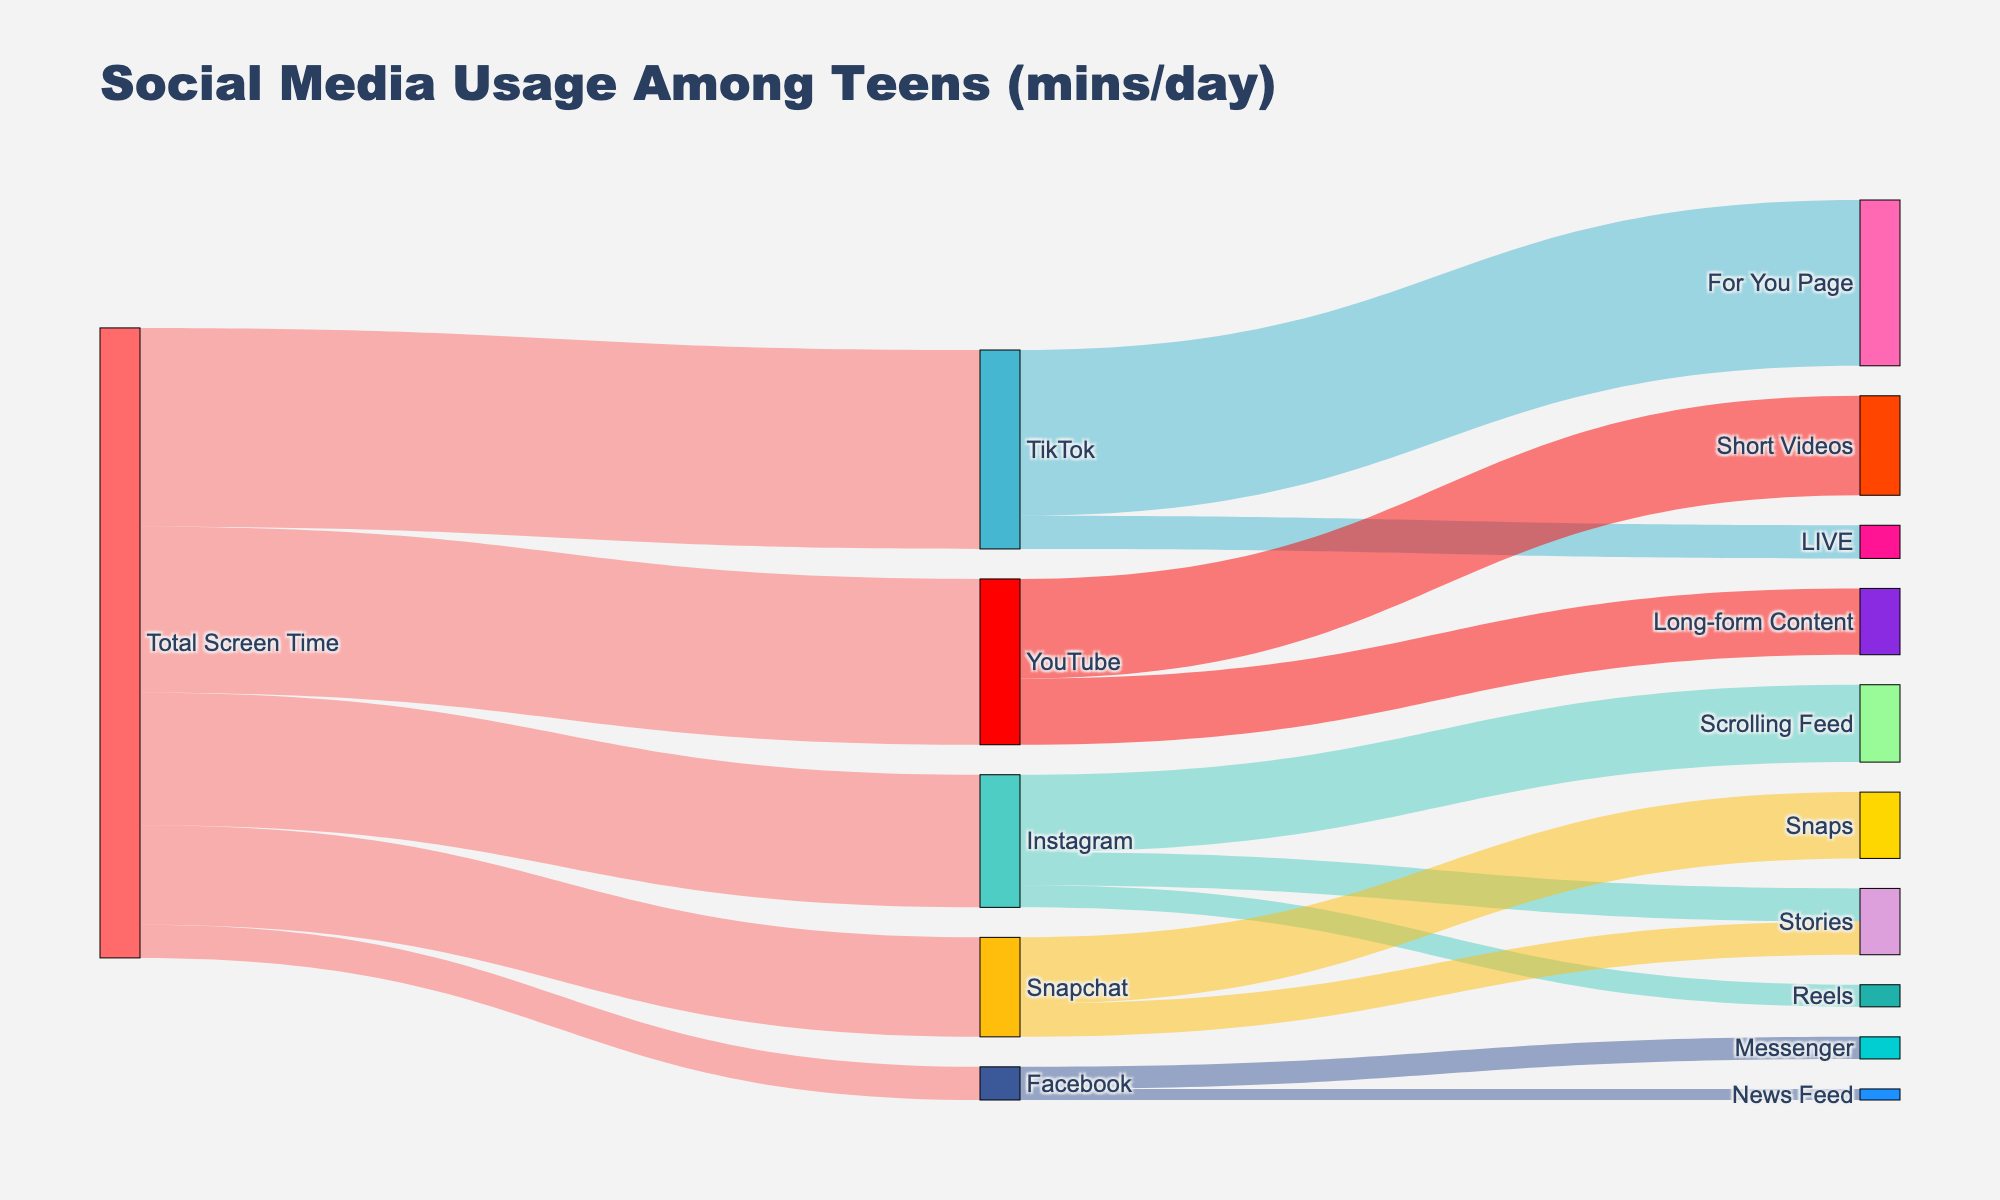Who spends the most time on social media platforms? The figure shows the total screen time for each platform: Instagram (120 mins), TikTok (180 mins), Snapchat (90 mins), YouTube (150 mins), and Facebook (30 mins). TikTok has the highest total screen time.
Answer: TikTok Which activity takes up the most time on YouTube? The diagram shows two activities for YouTube: Short Videos (90 mins) and Long-form Content (60 mins). Short Videos take up the most time.
Answer: Short Videos What is the total screen time spent on Instagram Stories and Reels combined? The screen time for Instagram Stories is 30 mins and for Instagram Reels is 20 mins. Adding these together gives 30 + 20 = 50 mins.
Answer: 50 mins How does the screen time on Snapchat Snaps compare to Facebook Messenger? The screen time for Snapchat Snaps is 60 mins, and for Facebook Messenger, it is 20 mins. 60 mins is three times greater than 20 mins.
Answer: Snapchat Snaps > Facebook Messenger What is the most common activity on TikTok? The diagram shows two activities for TikTok: For You Page (150 mins) and LIVE (30 mins). The For You Page is the most common activity with 150 mins.
Answer: For You Page How much screen time is spent on Scrolling Feed compared to Stories on Instagram? Scrolling Feed on Instagram has 70 mins of screen time, while Stories has 30 mins. Scrolling Feed has more screen time.
Answer: Scrolling Feed > Stories How much total time is spent on Stories across all platforms? Instagram Stories has 30 mins, and Snapchat Stories have 30 mins. Summing these gives 30 + 30 = 60 mins.
Answer: 60 mins Which platform has the least screen time? The platforms listed are Instagram, TikTok, Snapchat, YouTube, and Facebook with screen times of 120 mins, 180 mins, 90 mins, 150 mins, and 30 mins respectively. Facebook has the least screen time.
Answer: Facebook What percentage of TikTok's time is spent on the LIVE activity? TikTok's total screen time is 180 mins, and LIVE activity time is 30 mins. The percentage is (30/180) * 100 = 16.67%.
Answer: 16.67% If you add up the screen time spent on Instagram and YouTube, how much is it? Instagram has 120 mins, and YouTube has 150 mins. Adding these gives 120 + 150 = 270 mins.
Answer: 270 mins 